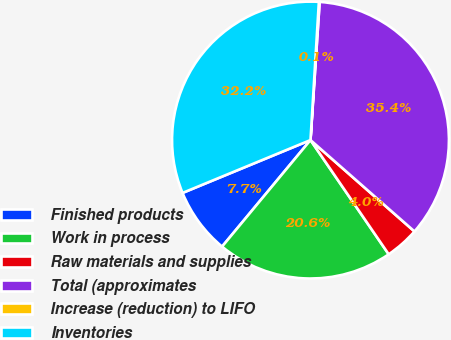Convert chart. <chart><loc_0><loc_0><loc_500><loc_500><pie_chart><fcel>Finished products<fcel>Work in process<fcel>Raw materials and supplies<fcel>Total (approximates<fcel>Increase (reduction) to LIFO<fcel>Inventories<nl><fcel>7.74%<fcel>20.58%<fcel>3.97%<fcel>35.42%<fcel>0.09%<fcel>32.2%<nl></chart> 